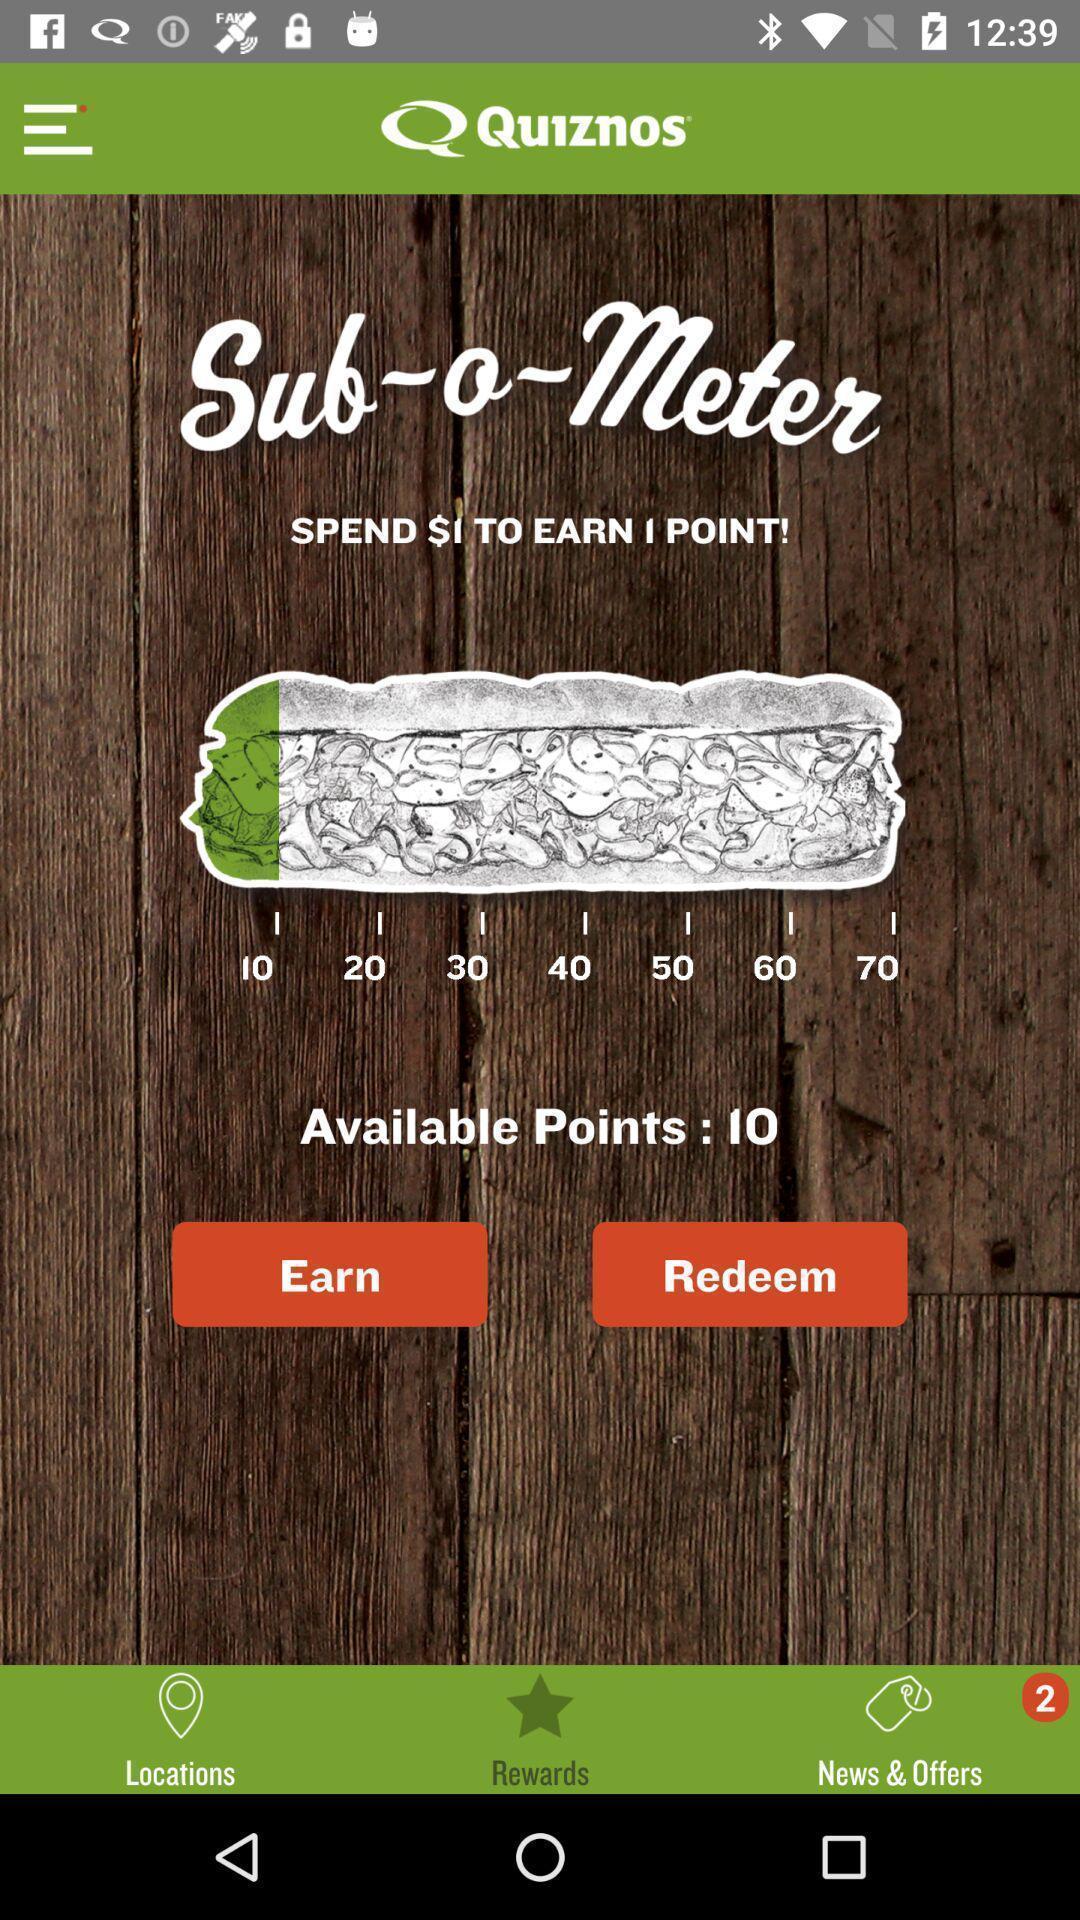What can you discern from this picture? Page showing earning points in the quiz app. 